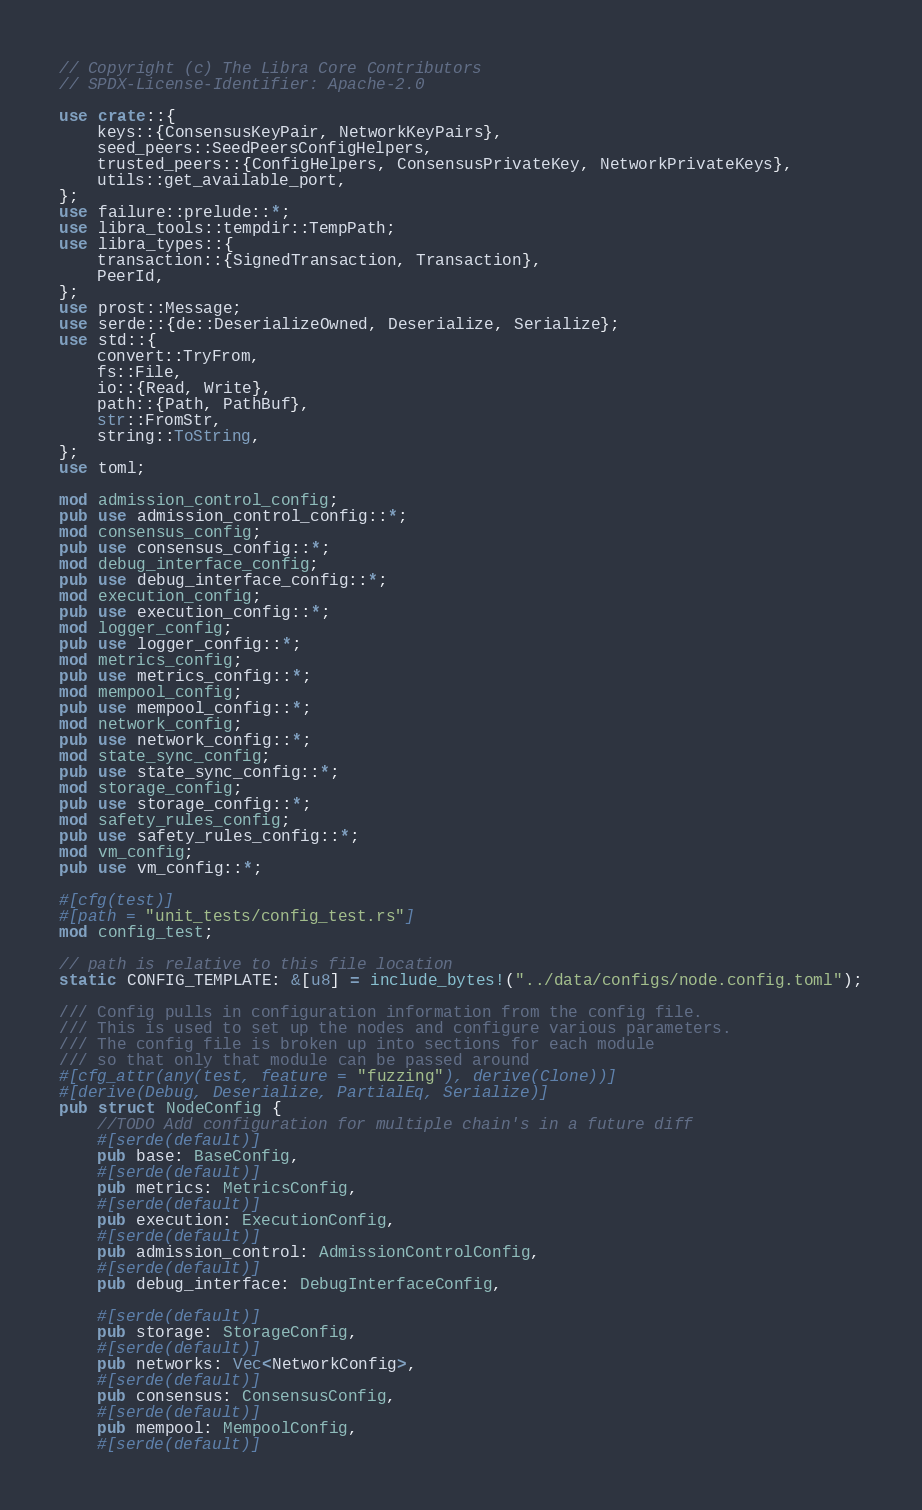Convert code to text. <code><loc_0><loc_0><loc_500><loc_500><_Rust_>// Copyright (c) The Libra Core Contributors
// SPDX-License-Identifier: Apache-2.0

use crate::{
    keys::{ConsensusKeyPair, NetworkKeyPairs},
    seed_peers::SeedPeersConfigHelpers,
    trusted_peers::{ConfigHelpers, ConsensusPrivateKey, NetworkPrivateKeys},
    utils::get_available_port,
};
use failure::prelude::*;
use libra_tools::tempdir::TempPath;
use libra_types::{
    transaction::{SignedTransaction, Transaction},
    PeerId,
};
use prost::Message;
use serde::{de::DeserializeOwned, Deserialize, Serialize};
use std::{
    convert::TryFrom,
    fs::File,
    io::{Read, Write},
    path::{Path, PathBuf},
    str::FromStr,
    string::ToString,
};
use toml;

mod admission_control_config;
pub use admission_control_config::*;
mod consensus_config;
pub use consensus_config::*;
mod debug_interface_config;
pub use debug_interface_config::*;
mod execution_config;
pub use execution_config::*;
mod logger_config;
pub use logger_config::*;
mod metrics_config;
pub use metrics_config::*;
mod mempool_config;
pub use mempool_config::*;
mod network_config;
pub use network_config::*;
mod state_sync_config;
pub use state_sync_config::*;
mod storage_config;
pub use storage_config::*;
mod safety_rules_config;
pub use safety_rules_config::*;
mod vm_config;
pub use vm_config::*;

#[cfg(test)]
#[path = "unit_tests/config_test.rs"]
mod config_test;

// path is relative to this file location
static CONFIG_TEMPLATE: &[u8] = include_bytes!("../data/configs/node.config.toml");

/// Config pulls in configuration information from the config file.
/// This is used to set up the nodes and configure various parameters.
/// The config file is broken up into sections for each module
/// so that only that module can be passed around
#[cfg_attr(any(test, feature = "fuzzing"), derive(Clone))]
#[derive(Debug, Deserialize, PartialEq, Serialize)]
pub struct NodeConfig {
    //TODO Add configuration for multiple chain's in a future diff
    #[serde(default)]
    pub base: BaseConfig,
    #[serde(default)]
    pub metrics: MetricsConfig,
    #[serde(default)]
    pub execution: ExecutionConfig,
    #[serde(default)]
    pub admission_control: AdmissionControlConfig,
    #[serde(default)]
    pub debug_interface: DebugInterfaceConfig,

    #[serde(default)]
    pub storage: StorageConfig,
    #[serde(default)]
    pub networks: Vec<NetworkConfig>,
    #[serde(default)]
    pub consensus: ConsensusConfig,
    #[serde(default)]
    pub mempool: MempoolConfig,
    #[serde(default)]</code> 